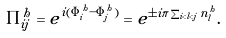<formula> <loc_0><loc_0><loc_500><loc_500>\Pi ^ { h } _ { i j } = e ^ { i ( \Phi ^ { h } _ { i } - \Phi ^ { h } _ { j } ) } = e ^ { \pm i \pi \sum _ { i < l < j } n _ { l } ^ { h } } .</formula> 